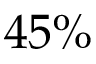<formula> <loc_0><loc_0><loc_500><loc_500>4 5 \%</formula> 